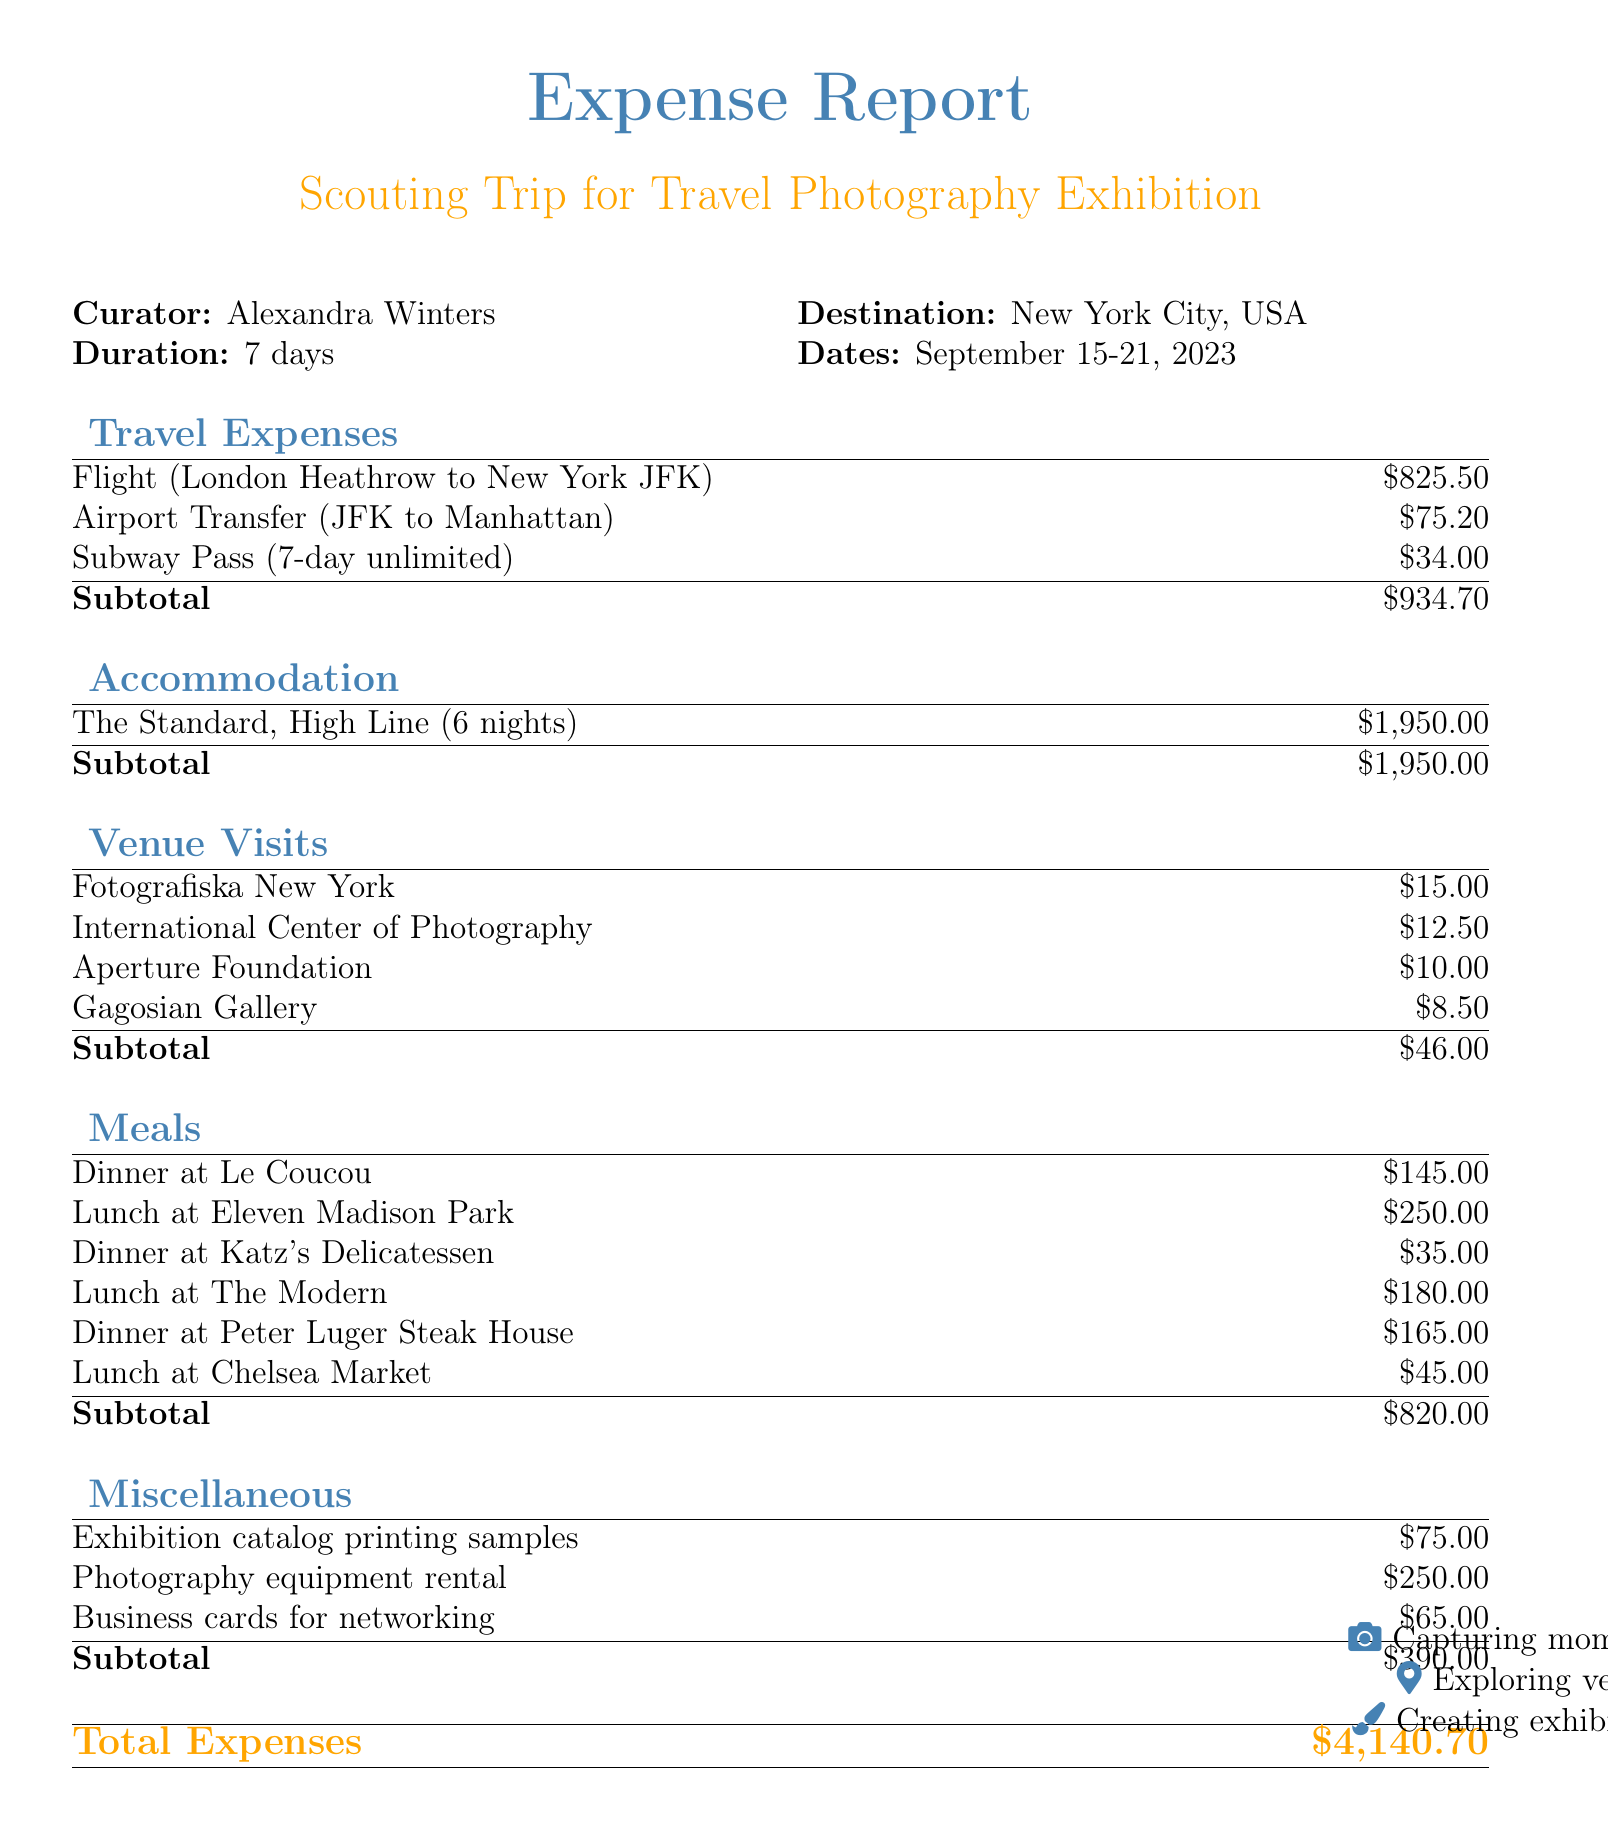What is the purpose of the trip? The purpose of the trip is to scout potential exhibition venues for a travel photography showcase.
Answer: Scouting potential exhibition venues for travel photography showcase Who is the curator of the trip? The document specifies that Alexandra Winters is the curator for this trip.
Answer: Alexandra Winters How many nights did the accommodation last? The duration of the accommodation mentioned is 6 nights.
Answer: 6 nights What is the total cost of travel expenses? The total travel expenses are detailed in the document and sum up to $934.70.
Answer: $934.70 Which venue was visited on September 17, 2023? The venue visit on this date is to the International Center of Photography.
Answer: International Center of Photography What was the cost for lunch with Sarah Thompson? The document states that lunch with Sarah Thompson at Eleven Madison Park cost $250.00.
Answer: $250.00 How much was spent on miscellaneous expenses? The total for miscellaneous expenses, as outlined in the document, is $390.00.
Answer: $390.00 What type of room was booked at the hotel? The accommodation details specify a King Room with City View was booked.
Answer: King Room with City View What is the total amount of expenses reported? The total amount of expenses across all categories in the document equals $4,140.70.
Answer: $4,140.70 